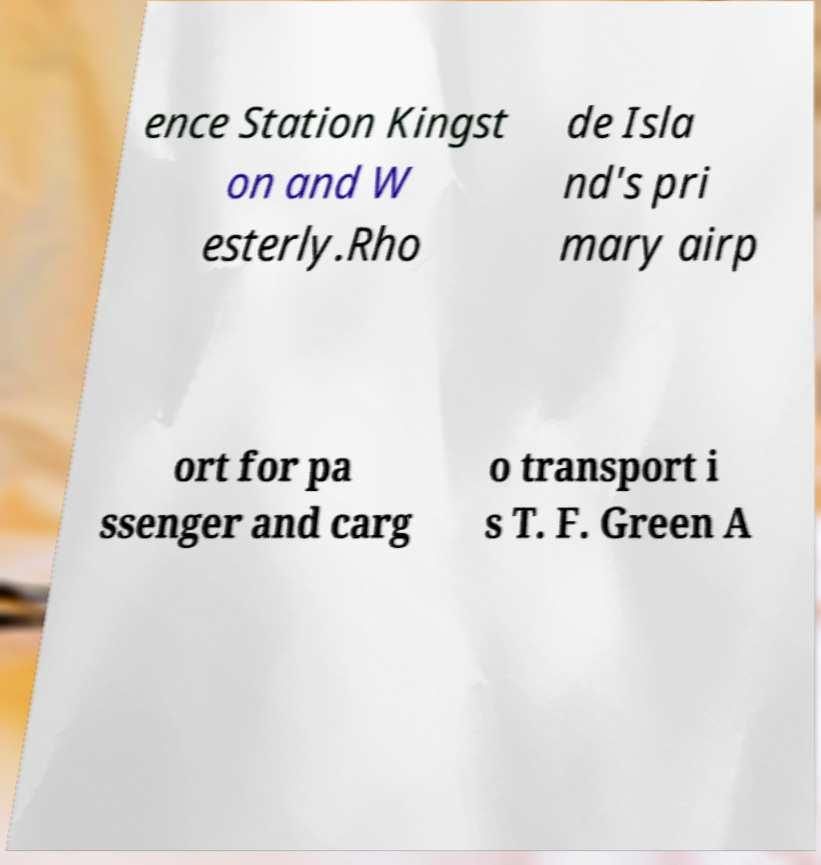Please identify and transcribe the text found in this image. ence Station Kingst on and W esterly.Rho de Isla nd's pri mary airp ort for pa ssenger and carg o transport i s T. F. Green A 